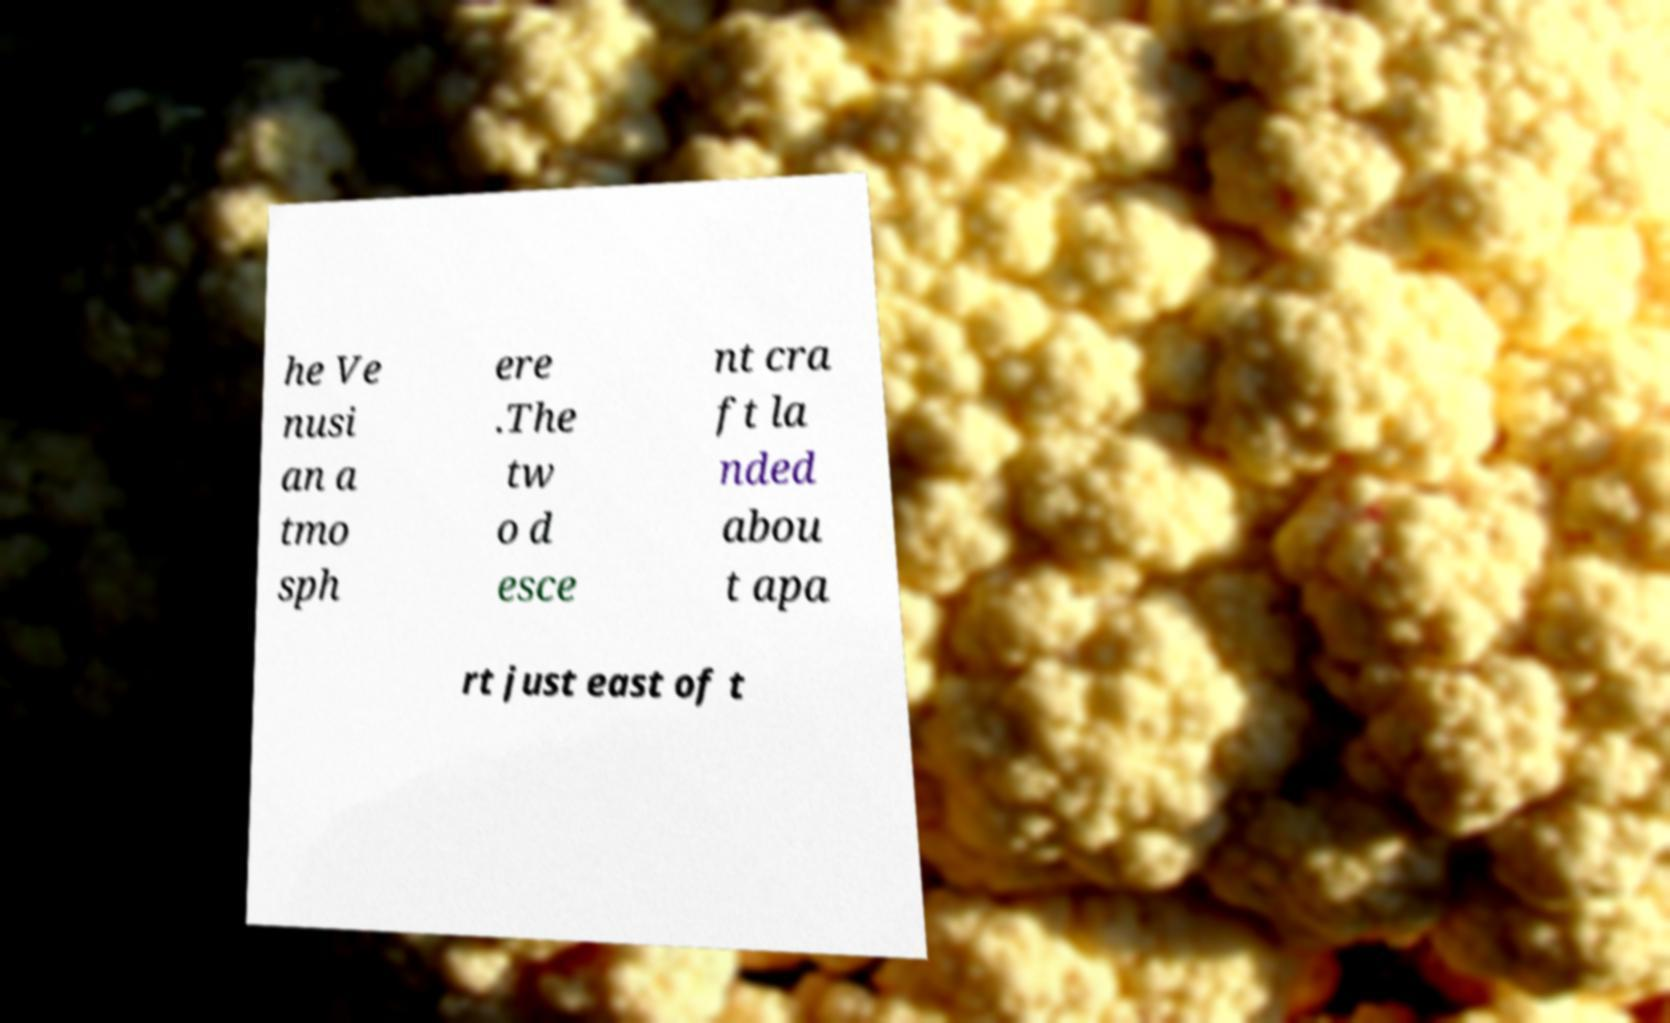Please read and relay the text visible in this image. What does it say? he Ve nusi an a tmo sph ere .The tw o d esce nt cra ft la nded abou t apa rt just east of t 